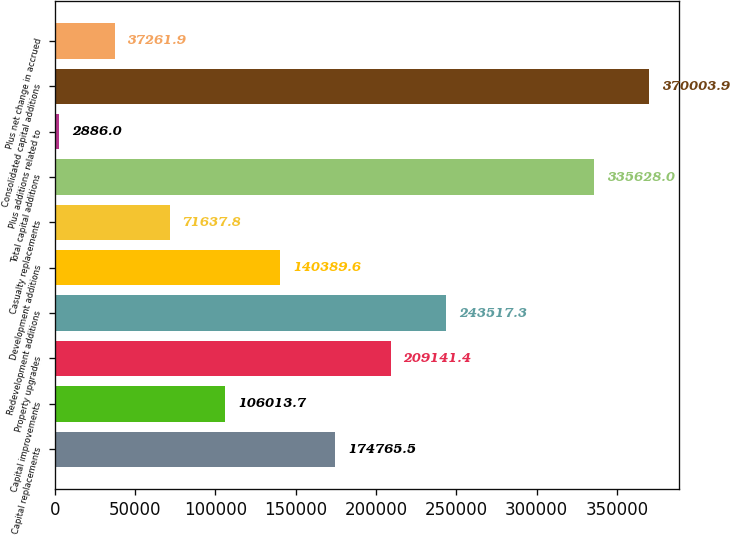Convert chart. <chart><loc_0><loc_0><loc_500><loc_500><bar_chart><fcel>Capital replacements<fcel>Capital improvements<fcel>Property upgrades<fcel>Redevelopment additions<fcel>Development additions<fcel>Casualty replacements<fcel>Total capital additions<fcel>Plus additions related to<fcel>Consolidated capital additions<fcel>Plus net change in accrued<nl><fcel>174766<fcel>106014<fcel>209141<fcel>243517<fcel>140390<fcel>71637.8<fcel>335628<fcel>2886<fcel>370004<fcel>37261.9<nl></chart> 